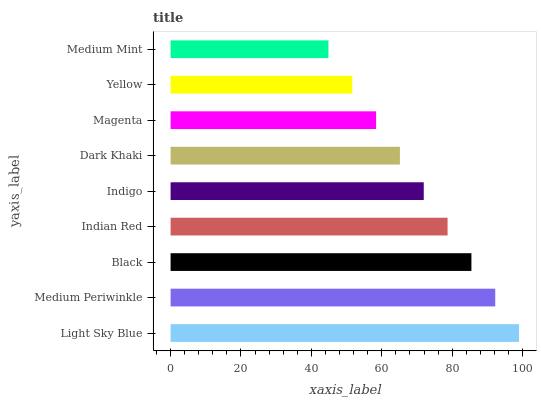Is Medium Mint the minimum?
Answer yes or no. Yes. Is Light Sky Blue the maximum?
Answer yes or no. Yes. Is Medium Periwinkle the minimum?
Answer yes or no. No. Is Medium Periwinkle the maximum?
Answer yes or no. No. Is Light Sky Blue greater than Medium Periwinkle?
Answer yes or no. Yes. Is Medium Periwinkle less than Light Sky Blue?
Answer yes or no. Yes. Is Medium Periwinkle greater than Light Sky Blue?
Answer yes or no. No. Is Light Sky Blue less than Medium Periwinkle?
Answer yes or no. No. Is Indigo the high median?
Answer yes or no. Yes. Is Indigo the low median?
Answer yes or no. Yes. Is Indian Red the high median?
Answer yes or no. No. Is Light Sky Blue the low median?
Answer yes or no. No. 